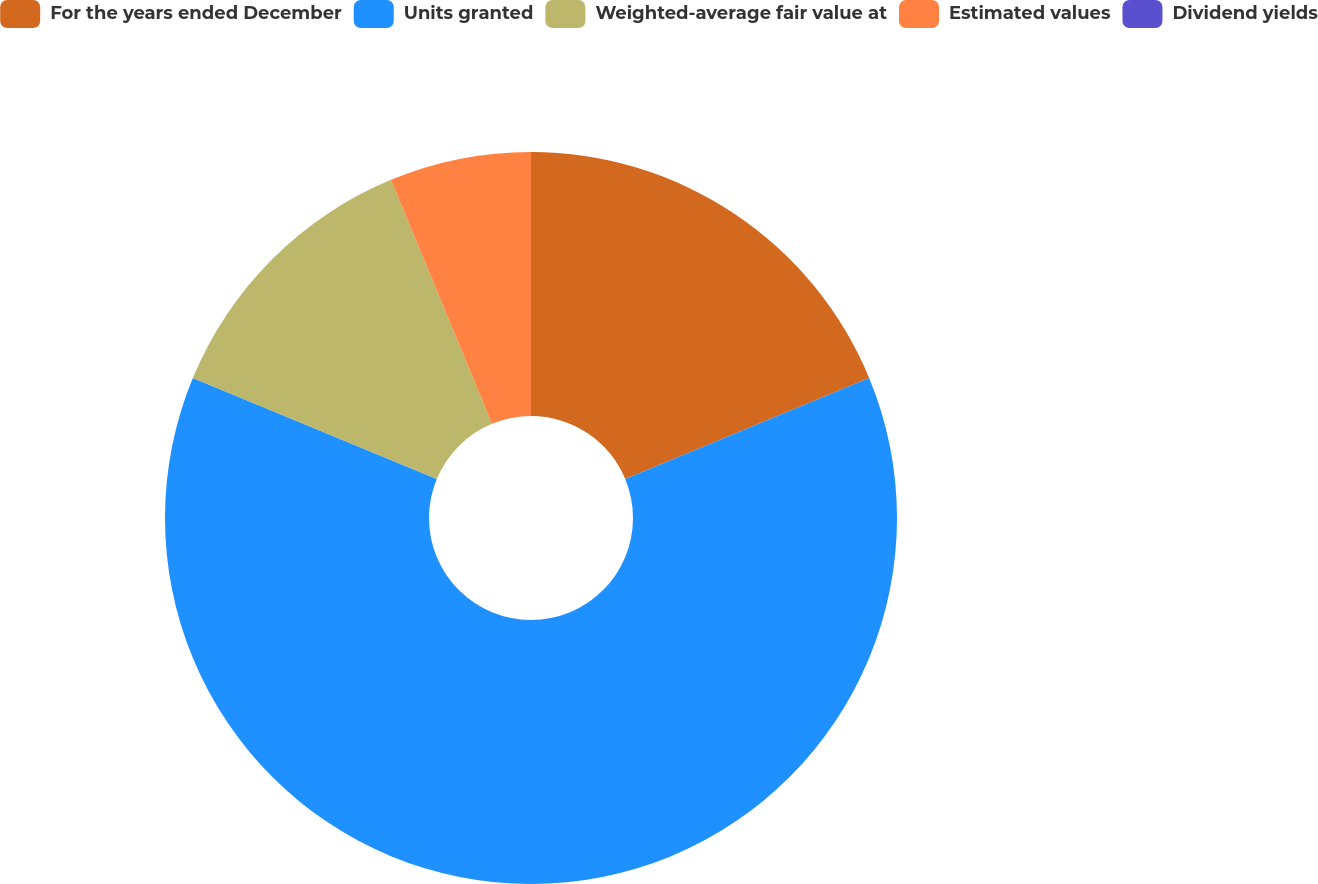Convert chart. <chart><loc_0><loc_0><loc_500><loc_500><pie_chart><fcel>For the years ended December<fcel>Units granted<fcel>Weighted-average fair value at<fcel>Estimated values<fcel>Dividend yields<nl><fcel>18.75%<fcel>62.5%<fcel>12.5%<fcel>6.25%<fcel>0.0%<nl></chart> 